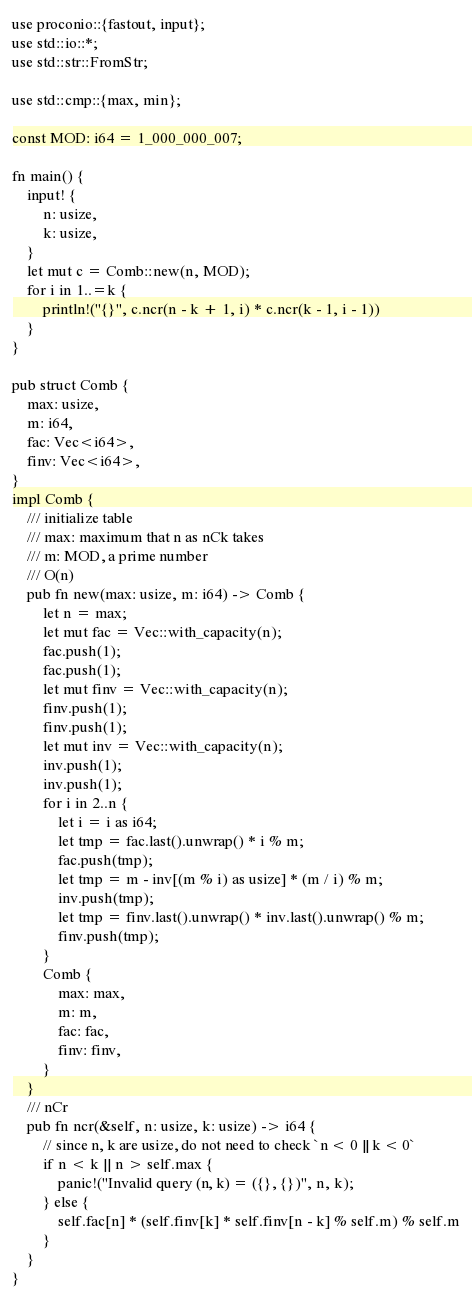<code> <loc_0><loc_0><loc_500><loc_500><_Rust_>use proconio::{fastout, input};
use std::io::*;
use std::str::FromStr;

use std::cmp::{max, min};

const MOD: i64 = 1_000_000_007;

fn main() {
    input! {
        n: usize,
        k: usize,
    }
    let mut c = Comb::new(n, MOD);
    for i in 1..=k {
        println!("{}", c.ncr(n - k + 1, i) * c.ncr(k - 1, i - 1))
    }
}

pub struct Comb {
    max: usize,
    m: i64,
    fac: Vec<i64>,
    finv: Vec<i64>,
}
impl Comb {
    /// initialize table
    /// max: maximum that n as nCk takes
    /// m: MOD, a prime number
    /// O(n)
    pub fn new(max: usize, m: i64) -> Comb {
        let n = max;
        let mut fac = Vec::with_capacity(n);
        fac.push(1);
        fac.push(1);
        let mut finv = Vec::with_capacity(n);
        finv.push(1);
        finv.push(1);
        let mut inv = Vec::with_capacity(n);
        inv.push(1);
        inv.push(1);
        for i in 2..n {
            let i = i as i64;
            let tmp = fac.last().unwrap() * i % m;
            fac.push(tmp);
            let tmp = m - inv[(m % i) as usize] * (m / i) % m;
            inv.push(tmp);
            let tmp = finv.last().unwrap() * inv.last().unwrap() % m;
            finv.push(tmp);
        }
        Comb {
            max: max,
            m: m,
            fac: fac,
            finv: finv,
        }
    }
    /// nCr
    pub fn ncr(&self, n: usize, k: usize) -> i64 {
        // since n, k are usize, do not need to check `n < 0 || k < 0`
        if n < k || n > self.max {
            panic!("Invalid query (n, k) = ({}, {})", n, k);
        } else {
            self.fac[n] * (self.finv[k] * self.finv[n - k] % self.m) % self.m
        }
    }
}
</code> 